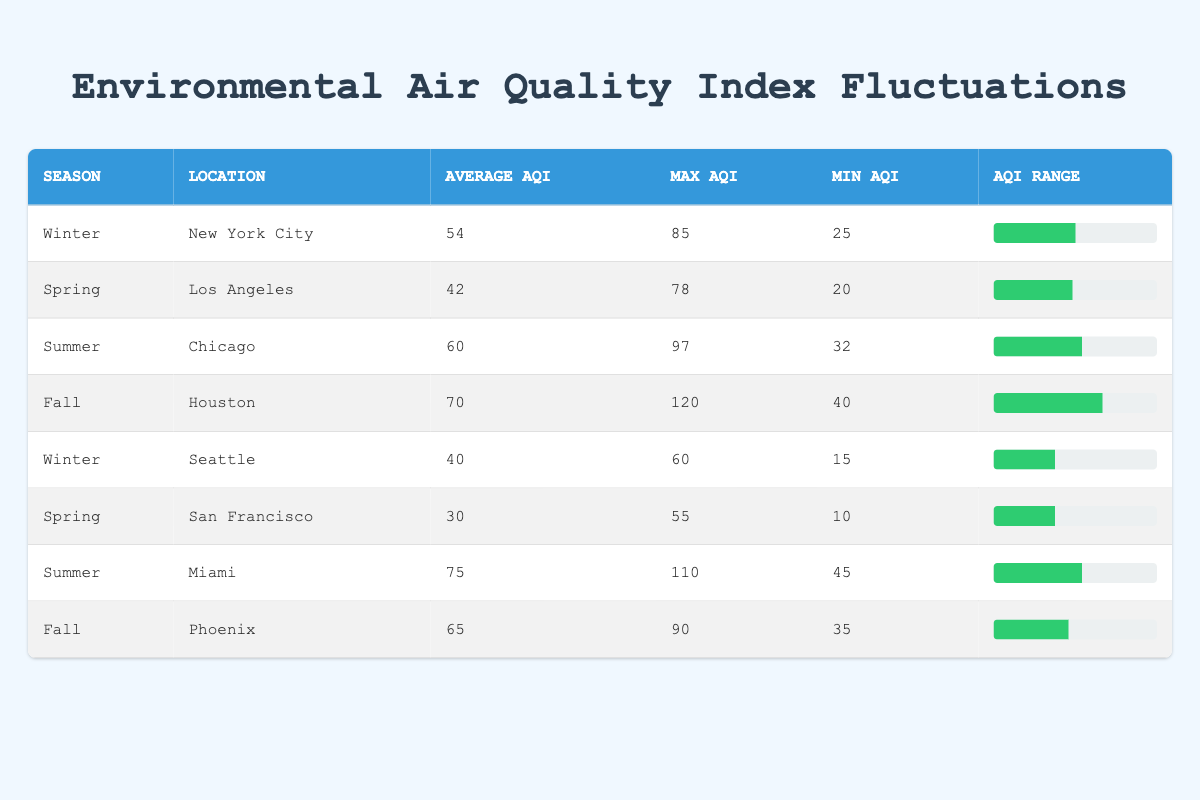What is the average AQI in Spring for Los Angeles? The average AQI for Los Angeles in Spring is listed in the table as 42.
Answer: 42 Which city has the highest Min AQI in the Fall season? Checking the table for Fall, Houston has a Min AQI of 40, while Phoenix has a Min AQI of 35. Therefore, Houston has the highest Min AQI for Fall.
Answer: Houston Is the Average AQI in Winter for New York City greater than that of Seattle? The Average AQI for New York City in Winter is 54, and for Seattle, it is 40. Since 54 is greater than 40, the statement is true.
Answer: Yes How much higher is the Max AQI in Summer for Miami compared to Summer in Chicago? The Max AQI for Miami in Summer is 110 and for Chicago it is 97. Calculating the difference gives 110 - 97 = 13, so Miami's Max AQI is 13 higher than Chicago's.
Answer: 13 What is the Average AQI of all cities in Fall? The Average AQI for Fall can be calculated by adding the Average AQIs for Houston (70) and Phoenix (65), leading to a total of 135. Dividing by the number of cities (2) gives an average of 135 / 2 = 67.5.
Answer: 67.5 In which season does Miami have an Average AQI that exceeds 70? According to the table, Miami's Average AQI during Summer is 75, which exceeds 70. Therefore, Miami has an Average AQI over 70 during Summer.
Answer: Summer What is the AQI range for the Winter season in New York City? The AQI range can be found by subtracting the Min AQI (25) from the Max AQI (85) for New York City in Winter. So, the range is 85 - 25 = 60.
Answer: 60 Which location has the lowest Average AQI across all seasons? By comparing the Average AQI values across all locations and seasons, San Francisco has the lowest Average AQI at 30 in Spring.
Answer: San Francisco Is there a city that has a Max AQI of 120? Looking at the table, Houston's Max AQI in Fall is 120, confirming that such a city exists.
Answer: Yes 